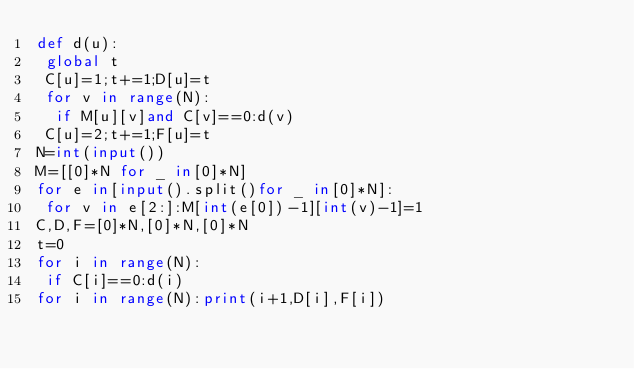<code> <loc_0><loc_0><loc_500><loc_500><_Python_>def d(u):
 global t
 C[u]=1;t+=1;D[u]=t
 for v in range(N):
  if M[u][v]and C[v]==0:d(v)
 C[u]=2;t+=1;F[u]=t
N=int(input())
M=[[0]*N for _ in[0]*N]
for e in[input().split()for _ in[0]*N]:
 for v in e[2:]:M[int(e[0])-1][int(v)-1]=1
C,D,F=[0]*N,[0]*N,[0]*N
t=0
for i in range(N):
 if C[i]==0:d(i)
for i in range(N):print(i+1,D[i],F[i])
</code> 